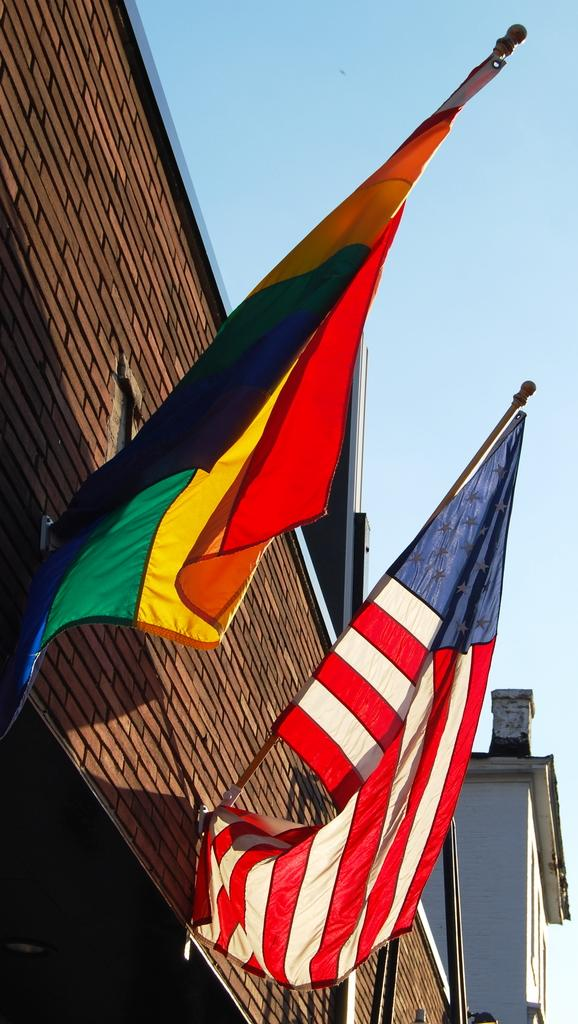What is the main structure visible in the image? There is a wall of a building in the image. What are the poles attached to the wall used for? The poles attached to the wall are used to hold flags. What can be seen on the poles? There are flags on the poles. What is visible at the top of the image? The sky is visible at the top of the image. How do the friends balance on the wheel in the image? There is no wheel or friends present in the image; it features a wall of a building with poles and flags. 